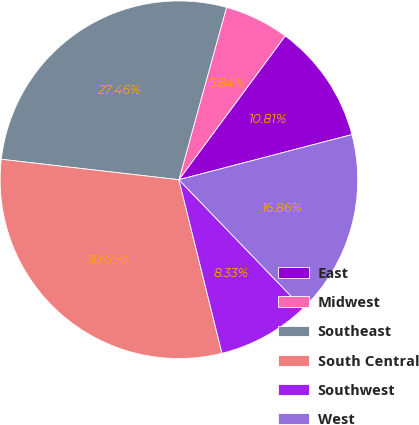Convert chart. <chart><loc_0><loc_0><loc_500><loc_500><pie_chart><fcel>East<fcel>Midwest<fcel>Southeast<fcel>South Central<fcel>Southwest<fcel>West<nl><fcel>10.81%<fcel>5.84%<fcel>27.46%<fcel>30.69%<fcel>8.33%<fcel>16.86%<nl></chart> 